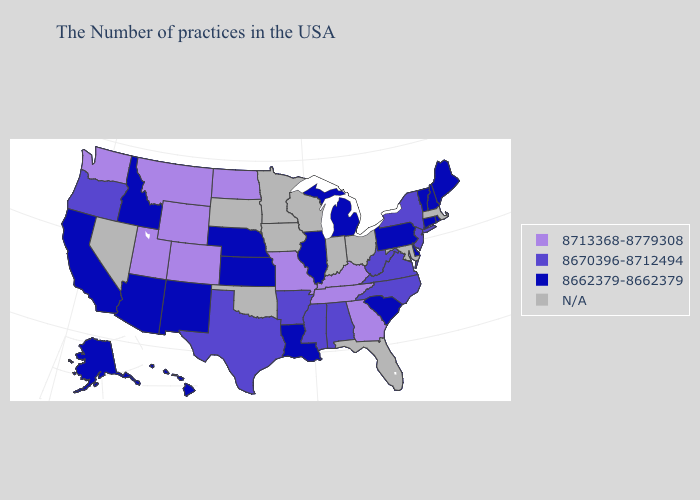What is the value of Vermont?
Write a very short answer. 8662379-8662379. Name the states that have a value in the range 8713368-8779308?
Answer briefly. Georgia, Kentucky, Tennessee, Missouri, North Dakota, Wyoming, Colorado, Utah, Montana, Washington. Does Georgia have the lowest value in the USA?
Give a very brief answer. No. What is the lowest value in the USA?
Answer briefly. 8662379-8662379. Which states have the lowest value in the West?
Short answer required. New Mexico, Arizona, Idaho, California, Alaska, Hawaii. Name the states that have a value in the range 8662379-8662379?
Write a very short answer. Maine, Rhode Island, New Hampshire, Vermont, Connecticut, Delaware, Pennsylvania, South Carolina, Michigan, Illinois, Louisiana, Kansas, Nebraska, New Mexico, Arizona, Idaho, California, Alaska, Hawaii. Is the legend a continuous bar?
Concise answer only. No. What is the value of Illinois?
Short answer required. 8662379-8662379. Name the states that have a value in the range 8670396-8712494?
Keep it brief. New York, New Jersey, Virginia, North Carolina, West Virginia, Alabama, Mississippi, Arkansas, Texas, Oregon. Does South Carolina have the lowest value in the South?
Keep it brief. Yes. What is the value of Missouri?
Be succinct. 8713368-8779308. Which states have the lowest value in the USA?
Give a very brief answer. Maine, Rhode Island, New Hampshire, Vermont, Connecticut, Delaware, Pennsylvania, South Carolina, Michigan, Illinois, Louisiana, Kansas, Nebraska, New Mexico, Arizona, Idaho, California, Alaska, Hawaii. Name the states that have a value in the range 8662379-8662379?
Quick response, please. Maine, Rhode Island, New Hampshire, Vermont, Connecticut, Delaware, Pennsylvania, South Carolina, Michigan, Illinois, Louisiana, Kansas, Nebraska, New Mexico, Arizona, Idaho, California, Alaska, Hawaii. Does Arkansas have the highest value in the USA?
Answer briefly. No. What is the value of Nebraska?
Give a very brief answer. 8662379-8662379. 